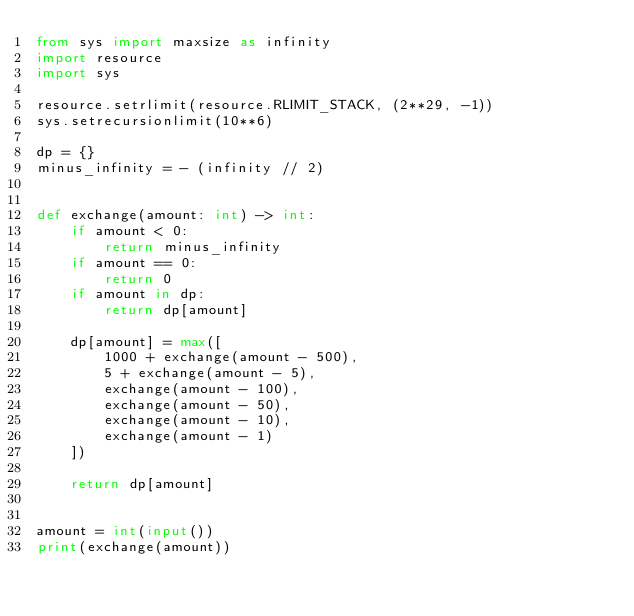Convert code to text. <code><loc_0><loc_0><loc_500><loc_500><_Python_>from sys import maxsize as infinity
import resource
import sys

resource.setrlimit(resource.RLIMIT_STACK, (2**29, -1))
sys.setrecursionlimit(10**6)

dp = {}
minus_infinity = - (infinity // 2)


def exchange(amount: int) -> int:
    if amount < 0:
        return minus_infinity
    if amount == 0:
        return 0
    if amount in dp:
        return dp[amount]

    dp[amount] = max([
        1000 + exchange(amount - 500),
        5 + exchange(amount - 5),
        exchange(amount - 100),
        exchange(amount - 50),
        exchange(amount - 10),
        exchange(amount - 1)
    ])

    return dp[amount]


amount = int(input())
print(exchange(amount))
</code> 